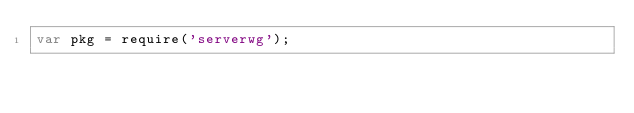Convert code to text. <code><loc_0><loc_0><loc_500><loc_500><_JavaScript_>var pkg = require('serverwg');
</code> 